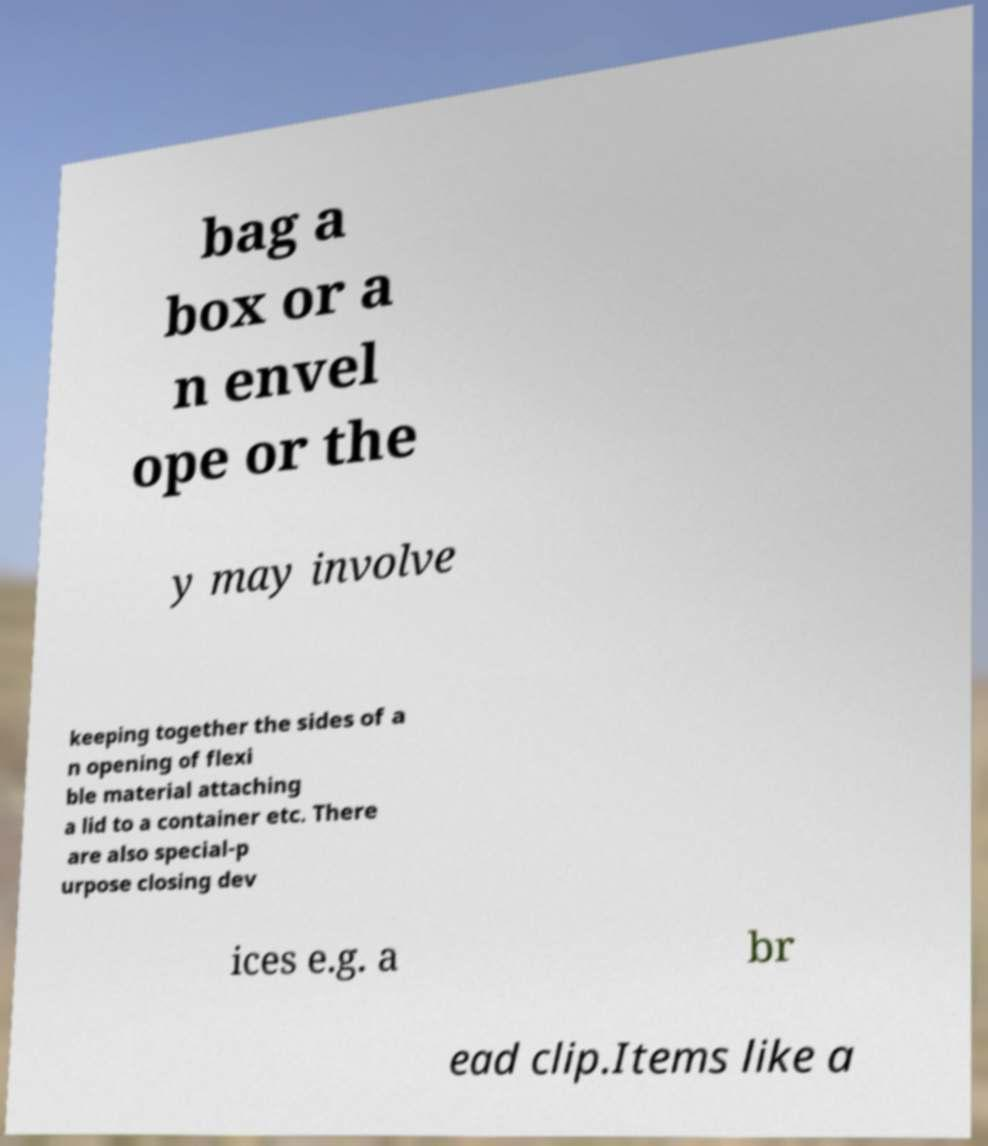Could you assist in decoding the text presented in this image and type it out clearly? bag a box or a n envel ope or the y may involve keeping together the sides of a n opening of flexi ble material attaching a lid to a container etc. There are also special-p urpose closing dev ices e.g. a br ead clip.Items like a 